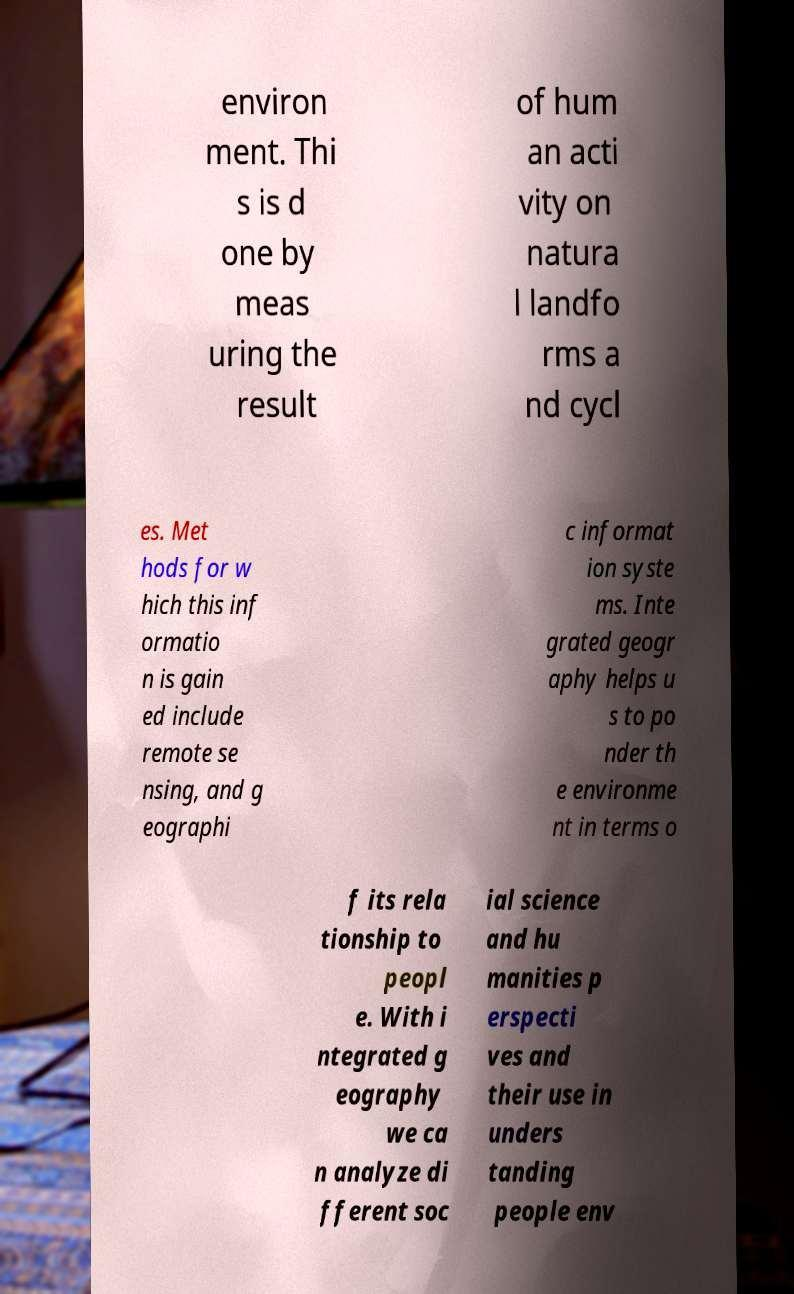Could you assist in decoding the text presented in this image and type it out clearly? environ ment. Thi s is d one by meas uring the result of hum an acti vity on natura l landfo rms a nd cycl es. Met hods for w hich this inf ormatio n is gain ed include remote se nsing, and g eographi c informat ion syste ms. Inte grated geogr aphy helps u s to po nder th e environme nt in terms o f its rela tionship to peopl e. With i ntegrated g eography we ca n analyze di fferent soc ial science and hu manities p erspecti ves and their use in unders tanding people env 